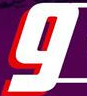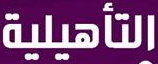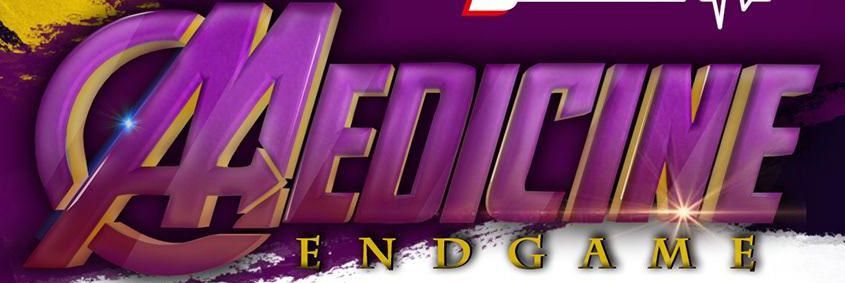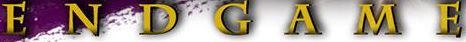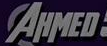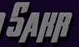What text appears in these images from left to right, separated by a semicolon? g; ###; MEDICINE; ENDGAME; AHMED; SAHR 